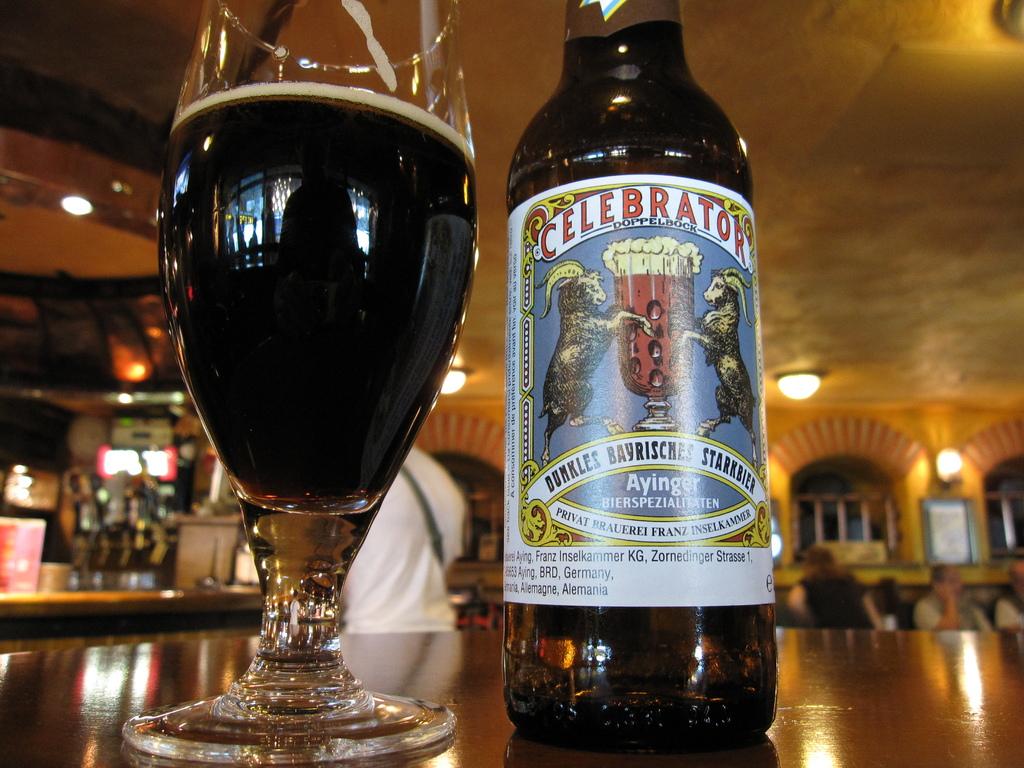What brand of beer is this?
Provide a succinct answer. Celebrator. What type of beer is it?
Provide a succinct answer. Celebrator. 